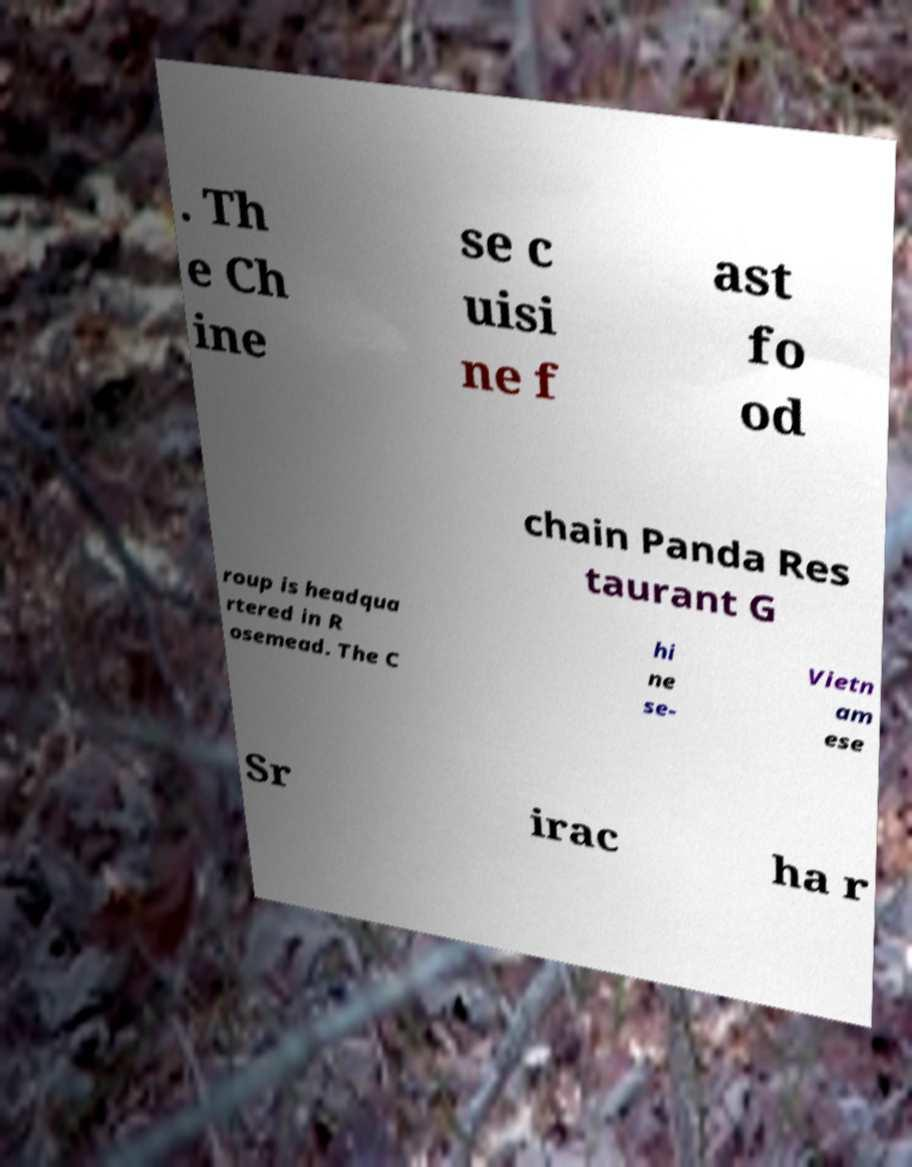There's text embedded in this image that I need extracted. Can you transcribe it verbatim? . Th e Ch ine se c uisi ne f ast fo od chain Panda Res taurant G roup is headqua rtered in R osemead. The C hi ne se- Vietn am ese Sr irac ha r 